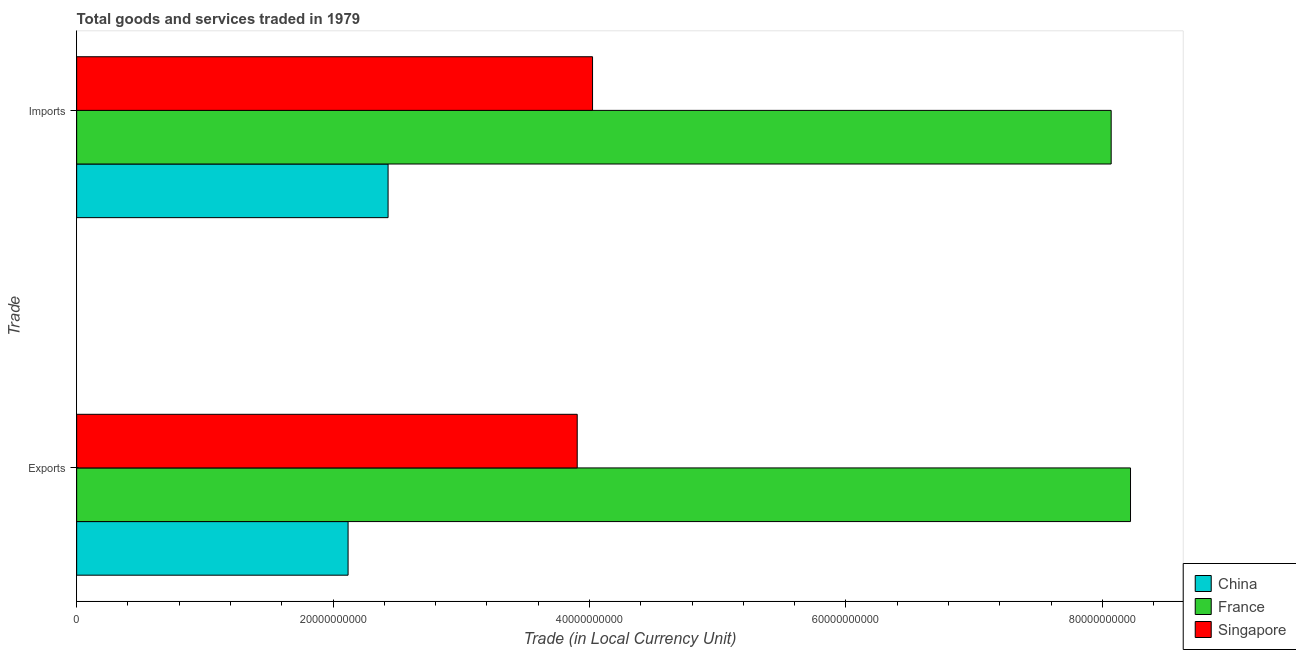How many different coloured bars are there?
Your answer should be very brief. 3. Are the number of bars per tick equal to the number of legend labels?
Give a very brief answer. Yes. How many bars are there on the 1st tick from the top?
Make the answer very short. 3. How many bars are there on the 2nd tick from the bottom?
Give a very brief answer. 3. What is the label of the 2nd group of bars from the top?
Make the answer very short. Exports. What is the export of goods and services in China?
Keep it short and to the point. 2.12e+1. Across all countries, what is the maximum imports of goods and services?
Your answer should be very brief. 8.07e+1. Across all countries, what is the minimum export of goods and services?
Offer a terse response. 2.12e+1. In which country was the imports of goods and services maximum?
Your answer should be very brief. France. In which country was the export of goods and services minimum?
Offer a very short reply. China. What is the total export of goods and services in the graph?
Make the answer very short. 1.42e+11. What is the difference between the export of goods and services in Singapore and that in China?
Your response must be concise. 1.79e+1. What is the difference between the imports of goods and services in Singapore and the export of goods and services in France?
Offer a very short reply. -4.20e+1. What is the average imports of goods and services per country?
Your answer should be very brief. 4.84e+1. What is the difference between the imports of goods and services and export of goods and services in Singapore?
Your answer should be very brief. 1.20e+09. What is the ratio of the export of goods and services in China to that in France?
Offer a very short reply. 0.26. Is the imports of goods and services in France less than that in Singapore?
Keep it short and to the point. No. What does the 2nd bar from the top in Imports represents?
Your response must be concise. France. What does the 3rd bar from the bottom in Exports represents?
Your answer should be very brief. Singapore. Are all the bars in the graph horizontal?
Make the answer very short. Yes. How many countries are there in the graph?
Keep it short and to the point. 3. What is the difference between two consecutive major ticks on the X-axis?
Your answer should be very brief. 2.00e+1. Are the values on the major ticks of X-axis written in scientific E-notation?
Keep it short and to the point. No. Does the graph contain any zero values?
Keep it short and to the point. No. Does the graph contain grids?
Keep it short and to the point. No. Where does the legend appear in the graph?
Keep it short and to the point. Bottom right. What is the title of the graph?
Give a very brief answer. Total goods and services traded in 1979. What is the label or title of the X-axis?
Provide a short and direct response. Trade (in Local Currency Unit). What is the label or title of the Y-axis?
Keep it short and to the point. Trade. What is the Trade (in Local Currency Unit) of China in Exports?
Offer a terse response. 2.12e+1. What is the Trade (in Local Currency Unit) in France in Exports?
Your answer should be compact. 8.22e+1. What is the Trade (in Local Currency Unit) of Singapore in Exports?
Your answer should be compact. 3.90e+1. What is the Trade (in Local Currency Unit) in China in Imports?
Make the answer very short. 2.43e+1. What is the Trade (in Local Currency Unit) of France in Imports?
Your answer should be very brief. 8.07e+1. What is the Trade (in Local Currency Unit) in Singapore in Imports?
Your response must be concise. 4.02e+1. Across all Trade, what is the maximum Trade (in Local Currency Unit) in China?
Make the answer very short. 2.43e+1. Across all Trade, what is the maximum Trade (in Local Currency Unit) in France?
Provide a short and direct response. 8.22e+1. Across all Trade, what is the maximum Trade (in Local Currency Unit) in Singapore?
Your answer should be very brief. 4.02e+1. Across all Trade, what is the minimum Trade (in Local Currency Unit) in China?
Your answer should be very brief. 2.12e+1. Across all Trade, what is the minimum Trade (in Local Currency Unit) in France?
Provide a short and direct response. 8.07e+1. Across all Trade, what is the minimum Trade (in Local Currency Unit) of Singapore?
Ensure brevity in your answer.  3.90e+1. What is the total Trade (in Local Currency Unit) of China in the graph?
Your response must be concise. 4.55e+1. What is the total Trade (in Local Currency Unit) of France in the graph?
Offer a very short reply. 1.63e+11. What is the total Trade (in Local Currency Unit) of Singapore in the graph?
Give a very brief answer. 7.93e+1. What is the difference between the Trade (in Local Currency Unit) in China in Exports and that in Imports?
Your answer should be very brief. -3.12e+09. What is the difference between the Trade (in Local Currency Unit) in France in Exports and that in Imports?
Provide a short and direct response. 1.51e+09. What is the difference between the Trade (in Local Currency Unit) of Singapore in Exports and that in Imports?
Offer a very short reply. -1.20e+09. What is the difference between the Trade (in Local Currency Unit) in China in Exports and the Trade (in Local Currency Unit) in France in Imports?
Keep it short and to the point. -5.95e+1. What is the difference between the Trade (in Local Currency Unit) of China in Exports and the Trade (in Local Currency Unit) of Singapore in Imports?
Keep it short and to the point. -1.91e+1. What is the difference between the Trade (in Local Currency Unit) in France in Exports and the Trade (in Local Currency Unit) in Singapore in Imports?
Ensure brevity in your answer.  4.20e+1. What is the average Trade (in Local Currency Unit) in China per Trade?
Your response must be concise. 2.27e+1. What is the average Trade (in Local Currency Unit) of France per Trade?
Provide a succinct answer. 8.14e+1. What is the average Trade (in Local Currency Unit) in Singapore per Trade?
Ensure brevity in your answer.  3.96e+1. What is the difference between the Trade (in Local Currency Unit) of China and Trade (in Local Currency Unit) of France in Exports?
Make the answer very short. -6.10e+1. What is the difference between the Trade (in Local Currency Unit) in China and Trade (in Local Currency Unit) in Singapore in Exports?
Offer a terse response. -1.79e+1. What is the difference between the Trade (in Local Currency Unit) of France and Trade (in Local Currency Unit) of Singapore in Exports?
Offer a terse response. 4.32e+1. What is the difference between the Trade (in Local Currency Unit) of China and Trade (in Local Currency Unit) of France in Imports?
Provide a short and direct response. -5.64e+1. What is the difference between the Trade (in Local Currency Unit) in China and Trade (in Local Currency Unit) in Singapore in Imports?
Make the answer very short. -1.59e+1. What is the difference between the Trade (in Local Currency Unit) of France and Trade (in Local Currency Unit) of Singapore in Imports?
Provide a succinct answer. 4.05e+1. What is the ratio of the Trade (in Local Currency Unit) of China in Exports to that in Imports?
Your answer should be compact. 0.87. What is the ratio of the Trade (in Local Currency Unit) of France in Exports to that in Imports?
Your response must be concise. 1.02. What is the ratio of the Trade (in Local Currency Unit) in Singapore in Exports to that in Imports?
Provide a short and direct response. 0.97. What is the difference between the highest and the second highest Trade (in Local Currency Unit) in China?
Offer a very short reply. 3.12e+09. What is the difference between the highest and the second highest Trade (in Local Currency Unit) in France?
Your answer should be compact. 1.51e+09. What is the difference between the highest and the second highest Trade (in Local Currency Unit) of Singapore?
Provide a short and direct response. 1.20e+09. What is the difference between the highest and the lowest Trade (in Local Currency Unit) of China?
Provide a succinct answer. 3.12e+09. What is the difference between the highest and the lowest Trade (in Local Currency Unit) of France?
Your response must be concise. 1.51e+09. What is the difference between the highest and the lowest Trade (in Local Currency Unit) in Singapore?
Make the answer very short. 1.20e+09. 